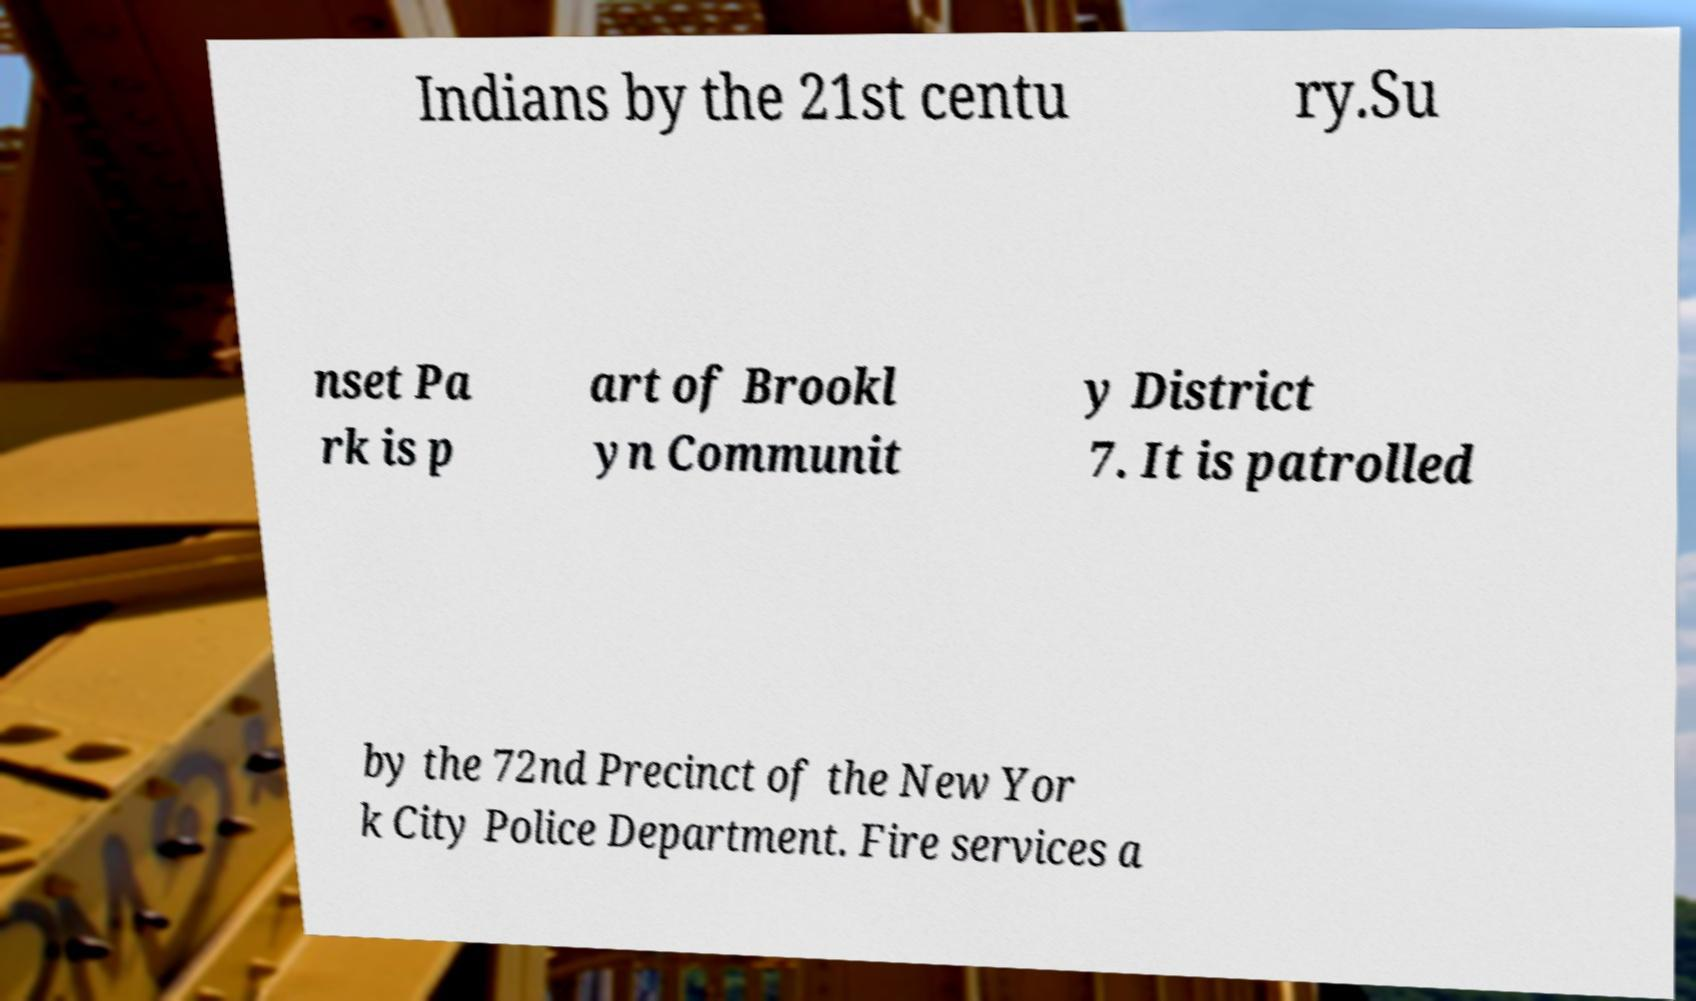Can you accurately transcribe the text from the provided image for me? Indians by the 21st centu ry.Su nset Pa rk is p art of Brookl yn Communit y District 7. It is patrolled by the 72nd Precinct of the New Yor k City Police Department. Fire services a 